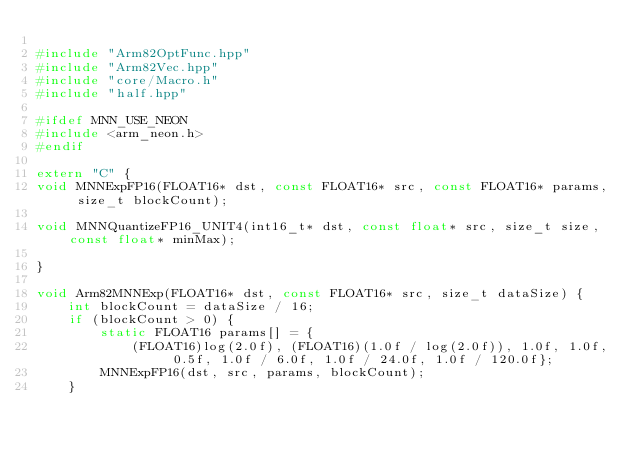Convert code to text. <code><loc_0><loc_0><loc_500><loc_500><_C++_>
#include "Arm82OptFunc.hpp"
#include "Arm82Vec.hpp"
#include "core/Macro.h"
#include "half.hpp"

#ifdef MNN_USE_NEON
#include <arm_neon.h>
#endif

extern "C" {
void MNNExpFP16(FLOAT16* dst, const FLOAT16* src, const FLOAT16* params, size_t blockCount);

void MNNQuantizeFP16_UNIT4(int16_t* dst, const float* src, size_t size, const float* minMax);

}

void Arm82MNNExp(FLOAT16* dst, const FLOAT16* src, size_t dataSize) {
    int blockCount = dataSize / 16;
    if (blockCount > 0) {
        static FLOAT16 params[] = {
            (FLOAT16)log(2.0f), (FLOAT16)(1.0f / log(2.0f)), 1.0f, 1.0f, 0.5f, 1.0f / 6.0f, 1.0f / 24.0f, 1.0f / 120.0f};
        MNNExpFP16(dst, src, params, blockCount);
    }</code> 